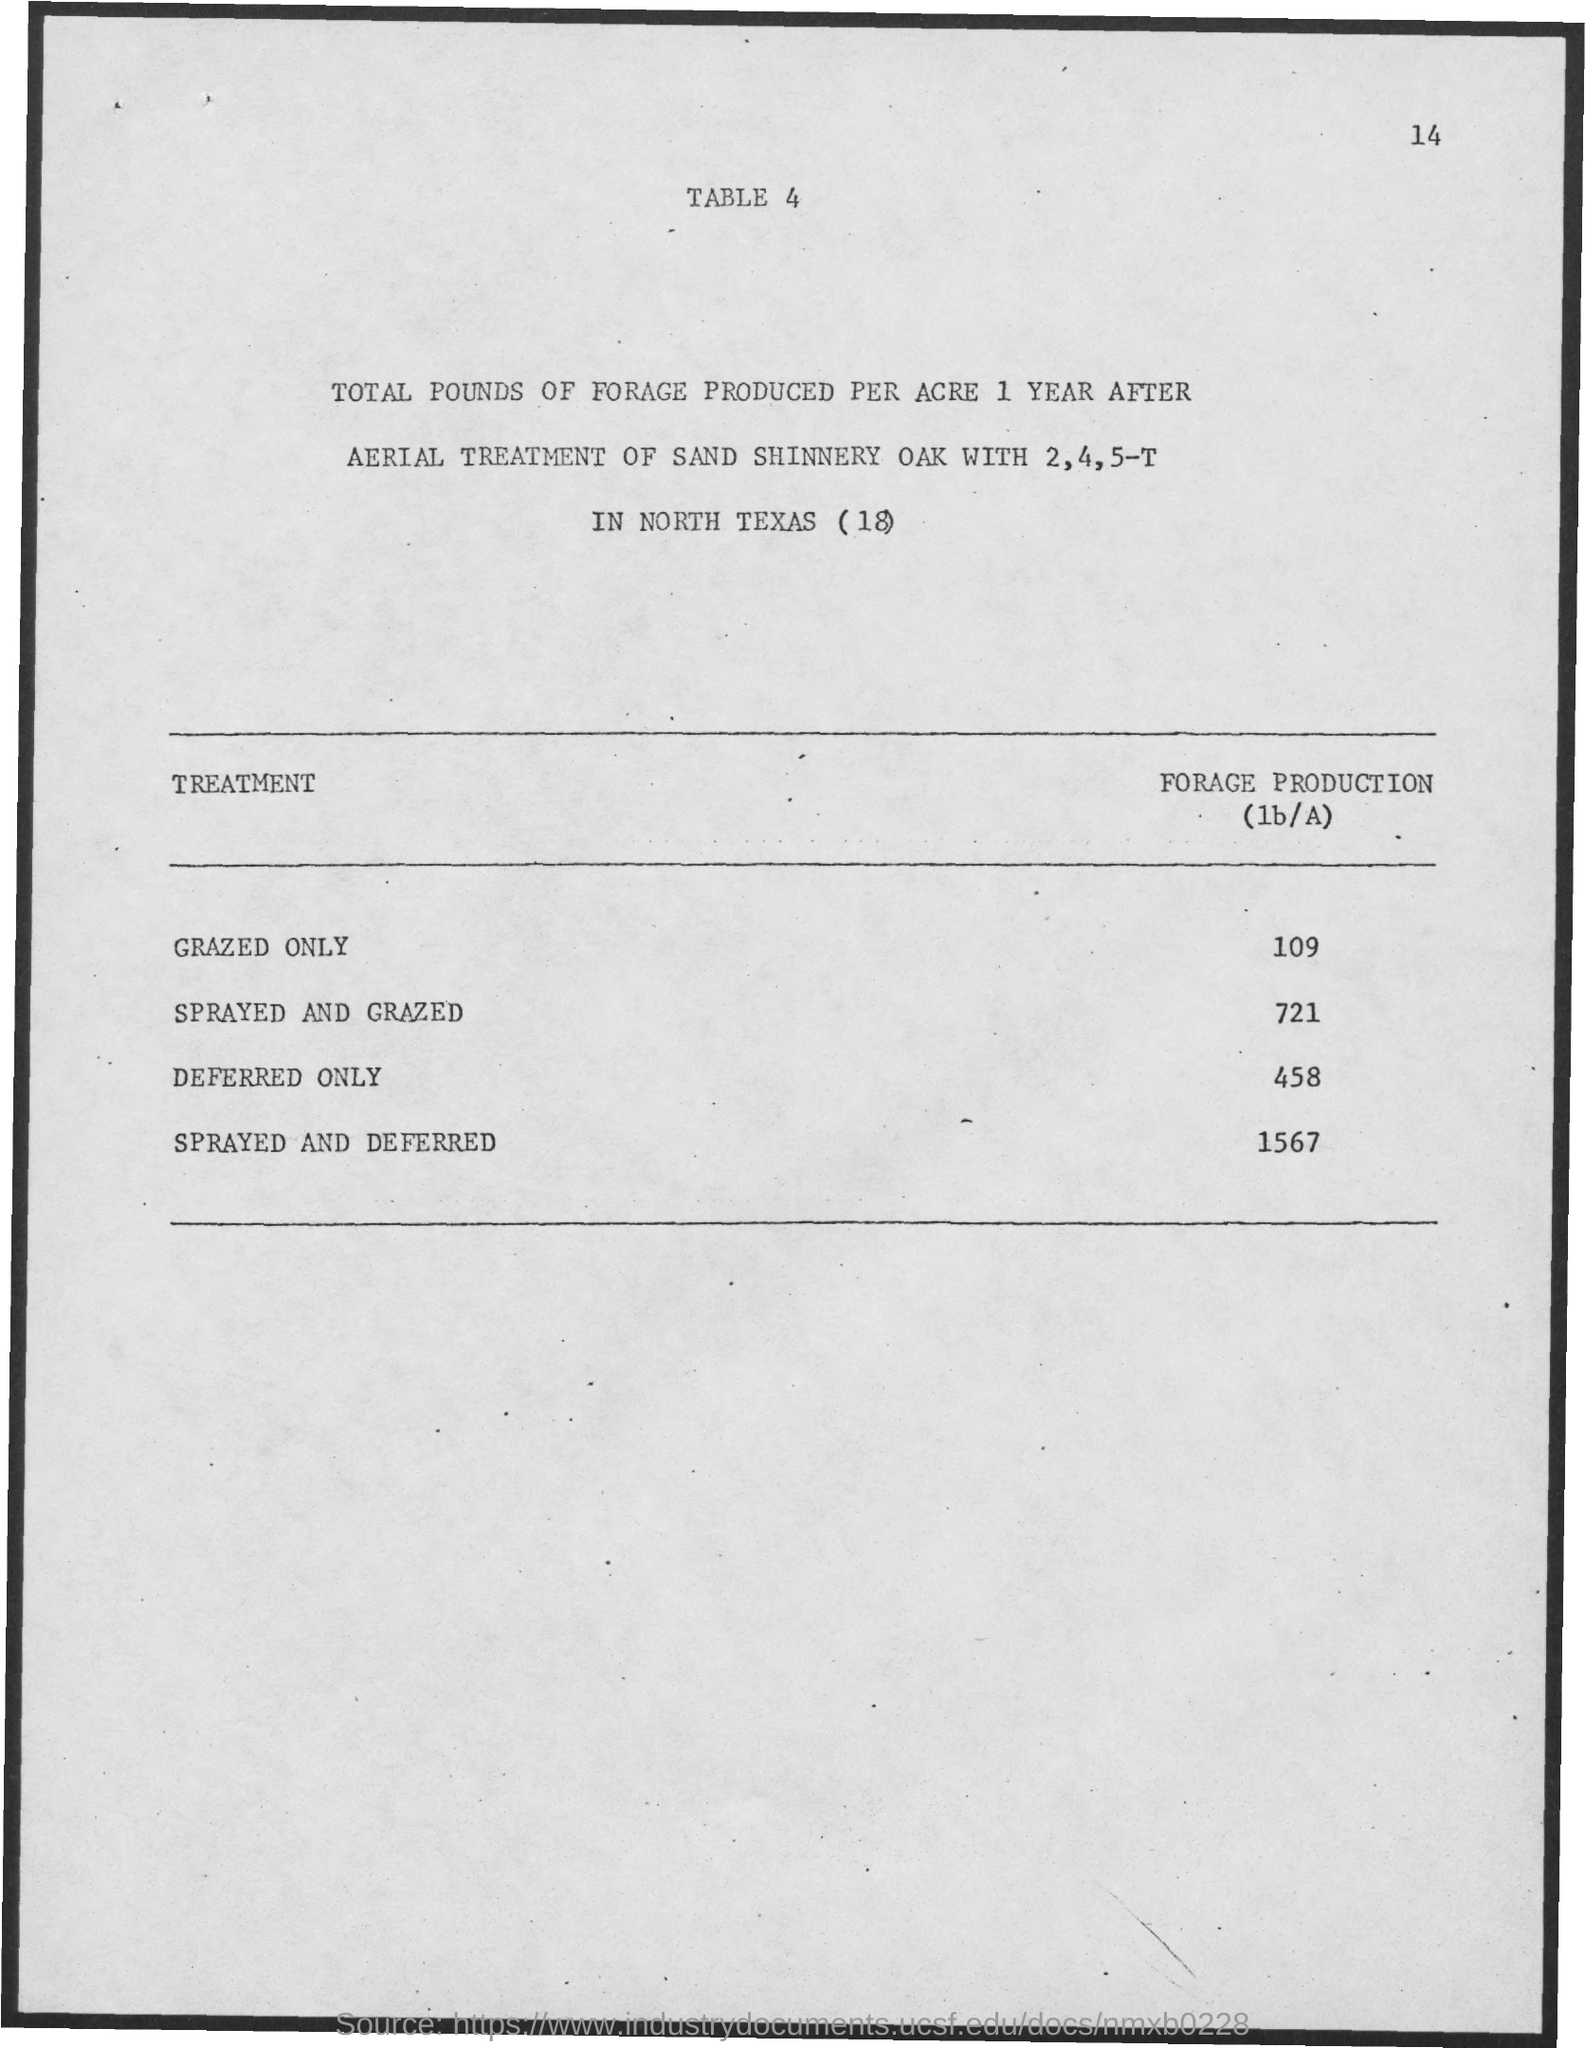Mention a couple of crucial points in this snapshot. The value of forage production for sprayed and deferred treatments is 1567. The value of forage production for sprayed and grazed is 721. The value of forage production for deferred only is 458. The value of forage production for grazed only is 109. 